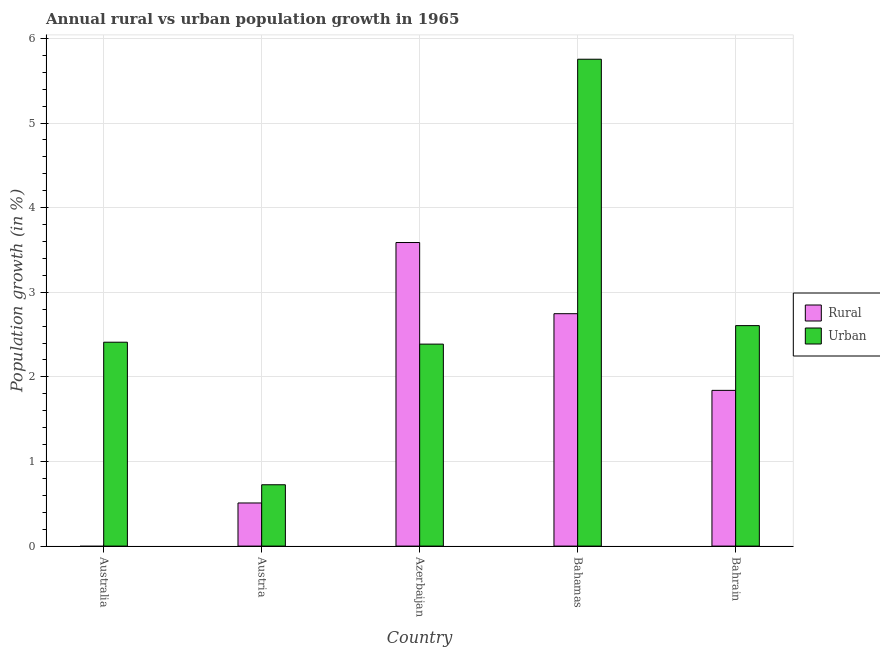How many different coloured bars are there?
Make the answer very short. 2. Are the number of bars per tick equal to the number of legend labels?
Keep it short and to the point. No. How many bars are there on the 4th tick from the left?
Make the answer very short. 2. How many bars are there on the 5th tick from the right?
Your answer should be compact. 1. What is the label of the 3rd group of bars from the left?
Your answer should be very brief. Azerbaijan. What is the rural population growth in Bahrain?
Your answer should be compact. 1.84. Across all countries, what is the maximum urban population growth?
Offer a very short reply. 5.75. In which country was the urban population growth maximum?
Keep it short and to the point. Bahamas. What is the total urban population growth in the graph?
Provide a short and direct response. 13.88. What is the difference between the urban population growth in Australia and that in Bahrain?
Offer a very short reply. -0.2. What is the difference between the urban population growth in Azerbaijan and the rural population growth in Austria?
Provide a short and direct response. 1.88. What is the average rural population growth per country?
Offer a terse response. 1.74. What is the difference between the urban population growth and rural population growth in Bahamas?
Your answer should be very brief. 3.01. What is the ratio of the urban population growth in Azerbaijan to that in Bahamas?
Your answer should be compact. 0.41. What is the difference between the highest and the second highest urban population growth?
Provide a short and direct response. 3.15. What is the difference between the highest and the lowest urban population growth?
Provide a short and direct response. 5.03. Is the sum of the rural population growth in Bahamas and Bahrain greater than the maximum urban population growth across all countries?
Give a very brief answer. No. Are all the bars in the graph horizontal?
Make the answer very short. No. How many countries are there in the graph?
Offer a very short reply. 5. Does the graph contain any zero values?
Offer a very short reply. Yes. What is the title of the graph?
Provide a short and direct response. Annual rural vs urban population growth in 1965. What is the label or title of the X-axis?
Ensure brevity in your answer.  Country. What is the label or title of the Y-axis?
Provide a succinct answer. Population growth (in %). What is the Population growth (in %) of Rural in Australia?
Provide a short and direct response. 0. What is the Population growth (in %) of Urban  in Australia?
Offer a terse response. 2.41. What is the Population growth (in %) of Rural in Austria?
Offer a terse response. 0.51. What is the Population growth (in %) in Urban  in Austria?
Make the answer very short. 0.73. What is the Population growth (in %) in Rural in Azerbaijan?
Keep it short and to the point. 3.59. What is the Population growth (in %) in Urban  in Azerbaijan?
Keep it short and to the point. 2.39. What is the Population growth (in %) of Rural in Bahamas?
Your response must be concise. 2.75. What is the Population growth (in %) in Urban  in Bahamas?
Keep it short and to the point. 5.75. What is the Population growth (in %) in Rural in Bahrain?
Your response must be concise. 1.84. What is the Population growth (in %) in Urban  in Bahrain?
Offer a terse response. 2.61. Across all countries, what is the maximum Population growth (in %) of Rural?
Ensure brevity in your answer.  3.59. Across all countries, what is the maximum Population growth (in %) of Urban ?
Your response must be concise. 5.75. Across all countries, what is the minimum Population growth (in %) in Urban ?
Provide a short and direct response. 0.73. What is the total Population growth (in %) in Rural in the graph?
Offer a terse response. 8.69. What is the total Population growth (in %) of Urban  in the graph?
Make the answer very short. 13.88. What is the difference between the Population growth (in %) in Urban  in Australia and that in Austria?
Keep it short and to the point. 1.68. What is the difference between the Population growth (in %) of Urban  in Australia and that in Azerbaijan?
Provide a succinct answer. 0.02. What is the difference between the Population growth (in %) in Urban  in Australia and that in Bahamas?
Provide a succinct answer. -3.34. What is the difference between the Population growth (in %) of Urban  in Australia and that in Bahrain?
Ensure brevity in your answer.  -0.2. What is the difference between the Population growth (in %) in Rural in Austria and that in Azerbaijan?
Provide a short and direct response. -3.08. What is the difference between the Population growth (in %) in Urban  in Austria and that in Azerbaijan?
Provide a short and direct response. -1.66. What is the difference between the Population growth (in %) of Rural in Austria and that in Bahamas?
Ensure brevity in your answer.  -2.24. What is the difference between the Population growth (in %) of Urban  in Austria and that in Bahamas?
Offer a terse response. -5.03. What is the difference between the Population growth (in %) of Rural in Austria and that in Bahrain?
Give a very brief answer. -1.33. What is the difference between the Population growth (in %) of Urban  in Austria and that in Bahrain?
Your response must be concise. -1.88. What is the difference between the Population growth (in %) in Rural in Azerbaijan and that in Bahamas?
Provide a succinct answer. 0.84. What is the difference between the Population growth (in %) of Urban  in Azerbaijan and that in Bahamas?
Offer a very short reply. -3.37. What is the difference between the Population growth (in %) of Rural in Azerbaijan and that in Bahrain?
Your answer should be very brief. 1.75. What is the difference between the Population growth (in %) in Urban  in Azerbaijan and that in Bahrain?
Provide a succinct answer. -0.22. What is the difference between the Population growth (in %) in Rural in Bahamas and that in Bahrain?
Keep it short and to the point. 0.91. What is the difference between the Population growth (in %) of Urban  in Bahamas and that in Bahrain?
Your answer should be compact. 3.15. What is the difference between the Population growth (in %) in Rural in Austria and the Population growth (in %) in Urban  in Azerbaijan?
Your response must be concise. -1.88. What is the difference between the Population growth (in %) of Rural in Austria and the Population growth (in %) of Urban  in Bahamas?
Your answer should be compact. -5.25. What is the difference between the Population growth (in %) of Rural in Austria and the Population growth (in %) of Urban  in Bahrain?
Ensure brevity in your answer.  -2.1. What is the difference between the Population growth (in %) of Rural in Azerbaijan and the Population growth (in %) of Urban  in Bahamas?
Keep it short and to the point. -2.17. What is the difference between the Population growth (in %) in Rural in Azerbaijan and the Population growth (in %) in Urban  in Bahrain?
Make the answer very short. 0.98. What is the difference between the Population growth (in %) of Rural in Bahamas and the Population growth (in %) of Urban  in Bahrain?
Provide a succinct answer. 0.14. What is the average Population growth (in %) in Rural per country?
Offer a very short reply. 1.74. What is the average Population growth (in %) in Urban  per country?
Offer a terse response. 2.78. What is the difference between the Population growth (in %) in Rural and Population growth (in %) in Urban  in Austria?
Offer a very short reply. -0.22. What is the difference between the Population growth (in %) in Rural and Population growth (in %) in Urban  in Azerbaijan?
Provide a succinct answer. 1.2. What is the difference between the Population growth (in %) of Rural and Population growth (in %) of Urban  in Bahamas?
Ensure brevity in your answer.  -3.01. What is the difference between the Population growth (in %) of Rural and Population growth (in %) of Urban  in Bahrain?
Offer a terse response. -0.77. What is the ratio of the Population growth (in %) in Urban  in Australia to that in Austria?
Provide a short and direct response. 3.32. What is the ratio of the Population growth (in %) in Urban  in Australia to that in Azerbaijan?
Offer a terse response. 1.01. What is the ratio of the Population growth (in %) in Urban  in Australia to that in Bahamas?
Offer a terse response. 0.42. What is the ratio of the Population growth (in %) in Urban  in Australia to that in Bahrain?
Ensure brevity in your answer.  0.92. What is the ratio of the Population growth (in %) in Rural in Austria to that in Azerbaijan?
Your answer should be very brief. 0.14. What is the ratio of the Population growth (in %) of Urban  in Austria to that in Azerbaijan?
Provide a succinct answer. 0.3. What is the ratio of the Population growth (in %) in Rural in Austria to that in Bahamas?
Your answer should be compact. 0.19. What is the ratio of the Population growth (in %) in Urban  in Austria to that in Bahamas?
Make the answer very short. 0.13. What is the ratio of the Population growth (in %) of Rural in Austria to that in Bahrain?
Offer a very short reply. 0.28. What is the ratio of the Population growth (in %) of Urban  in Austria to that in Bahrain?
Keep it short and to the point. 0.28. What is the ratio of the Population growth (in %) of Rural in Azerbaijan to that in Bahamas?
Make the answer very short. 1.31. What is the ratio of the Population growth (in %) of Urban  in Azerbaijan to that in Bahamas?
Offer a terse response. 0.41. What is the ratio of the Population growth (in %) of Rural in Azerbaijan to that in Bahrain?
Your answer should be compact. 1.95. What is the ratio of the Population growth (in %) of Urban  in Azerbaijan to that in Bahrain?
Provide a short and direct response. 0.92. What is the ratio of the Population growth (in %) in Rural in Bahamas to that in Bahrain?
Your answer should be very brief. 1.49. What is the ratio of the Population growth (in %) in Urban  in Bahamas to that in Bahrain?
Your response must be concise. 2.21. What is the difference between the highest and the second highest Population growth (in %) of Rural?
Give a very brief answer. 0.84. What is the difference between the highest and the second highest Population growth (in %) of Urban ?
Your answer should be compact. 3.15. What is the difference between the highest and the lowest Population growth (in %) of Rural?
Your answer should be compact. 3.59. What is the difference between the highest and the lowest Population growth (in %) of Urban ?
Your response must be concise. 5.03. 